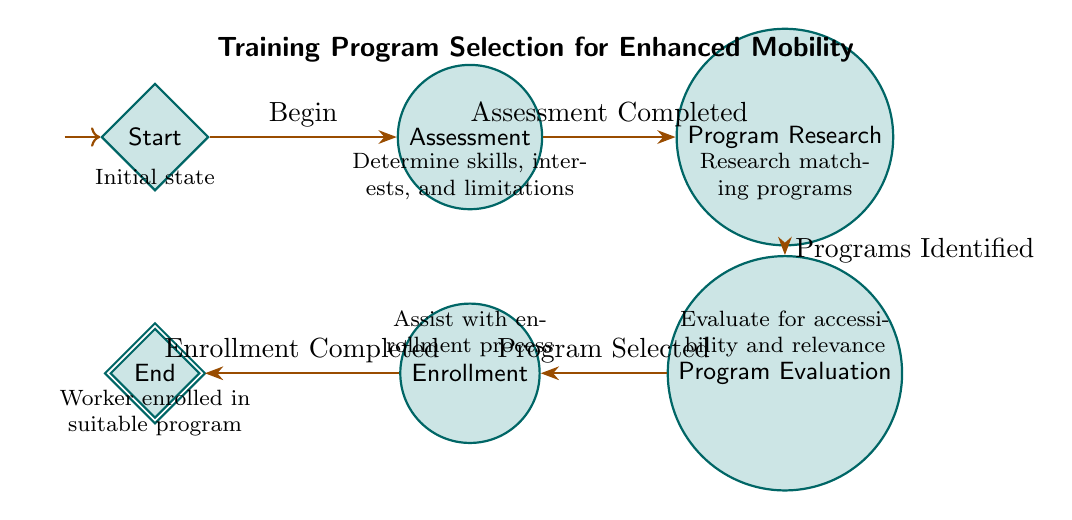What is the initial state in the diagram? The initial state is labeled as "Start" in the diagram. This is where the vocational counselor begins the process of assessing the worker.
Answer: Start How many nodes are present in the diagram? By counting each distinct state in the diagram, the total number of nodes is six: Start, Assessment, Program Research, Program Evaluation, Enrollment, and End.
Answer: Six What is the transition event from Assessment to Program Research? The transition from the Assessment state to the Program Research state occurs after the event "Assessment Completed" takes place, indicating completion of the assessment.
Answer: Assessment Completed Which state follows Program Evaluation? The state that follows Program Evaluation is Enrollment, as indicated by the transition flow from evaluation to the next state in the diagram.
Answer: Enrollment What needs to happen for the worker to move from Program Research to Program Evaluation? The worker must have "Programs Identified" in order to transition from the Program Research state to the Program Evaluation state. This event signifies that suitable training programs have been found.
Answer: Programs Identified What is the final state represented in the diagram? The final state in the diagram is labeled as "End," indicating the conclusion of the process once the worker has been enrolled in a suitable training program.
Answer: End What is the relationship between Program Research and Program Evaluation? The relationship between Program Research and Program Evaluation is sequential; specifically, Program Research must identify programs which, in turn, leads to Program Evaluation for further assessment.
Answer: Sequential What does the diagram represent as a whole? The diagram represents a Finite State Machine that outlines the steps a vocational counselor takes in selecting a training program for a worker with mobility limitations, detailing the transition through various stages.
Answer: Training program selection for enhanced mobility 